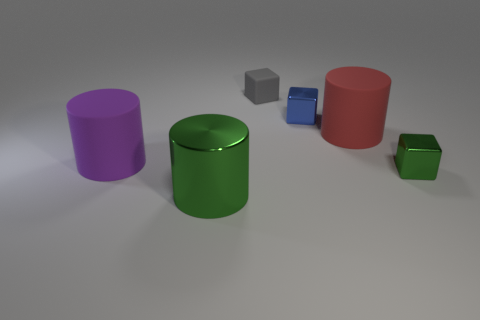There is a shiny thing behind the green metallic block; what is its color?
Offer a terse response. Blue. Is there a big rubber cylinder that is right of the big matte cylinder that is in front of the big red cylinder?
Your response must be concise. Yes. What number of things are either tiny objects on the right side of the gray object or tiny gray cubes?
Your answer should be compact. 3. The green object that is right of the small metallic object behind the tiny green metallic object is made of what material?
Ensure brevity in your answer.  Metal. Are there an equal number of big metal objects that are to the right of the red thing and big rubber cylinders behind the tiny gray rubber object?
Keep it short and to the point. Yes. How many objects are either green metallic objects that are to the right of the red rubber cylinder or metal objects that are in front of the tiny green cube?
Offer a very short reply. 2. What is the material of the thing that is both on the left side of the tiny blue metal cube and right of the big green object?
Ensure brevity in your answer.  Rubber. How big is the object on the left side of the green metal object that is left of the small metal thing to the right of the red matte object?
Make the answer very short. Large. Are there more purple rubber cylinders than tiny purple rubber balls?
Give a very brief answer. Yes. Is the material of the big cylinder right of the big metallic thing the same as the green cube?
Give a very brief answer. No. 